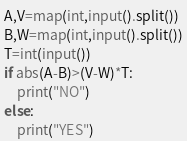<code> <loc_0><loc_0><loc_500><loc_500><_Python_>A,V=map(int,input().split())
B,W=map(int,input().split())
T=int(input())
if abs(A-B)>(V-W)*T:
    print("NO")
else:
    print("YES")</code> 